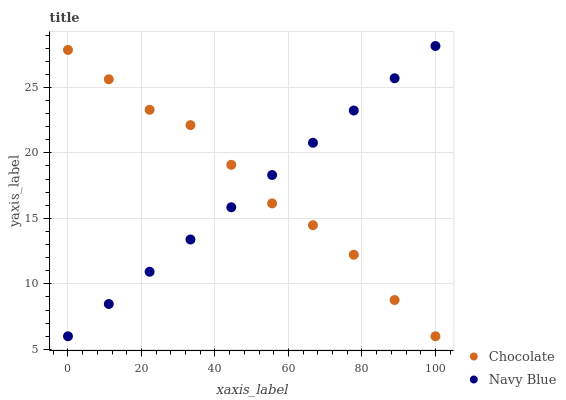Does Navy Blue have the minimum area under the curve?
Answer yes or no. Yes. Does Chocolate have the maximum area under the curve?
Answer yes or no. Yes. Does Chocolate have the minimum area under the curve?
Answer yes or no. No. Is Navy Blue the smoothest?
Answer yes or no. Yes. Is Chocolate the roughest?
Answer yes or no. Yes. Is Chocolate the smoothest?
Answer yes or no. No. Does Navy Blue have the lowest value?
Answer yes or no. Yes. Does Navy Blue have the highest value?
Answer yes or no. Yes. Does Chocolate have the highest value?
Answer yes or no. No. Does Chocolate intersect Navy Blue?
Answer yes or no. Yes. Is Chocolate less than Navy Blue?
Answer yes or no. No. Is Chocolate greater than Navy Blue?
Answer yes or no. No. 